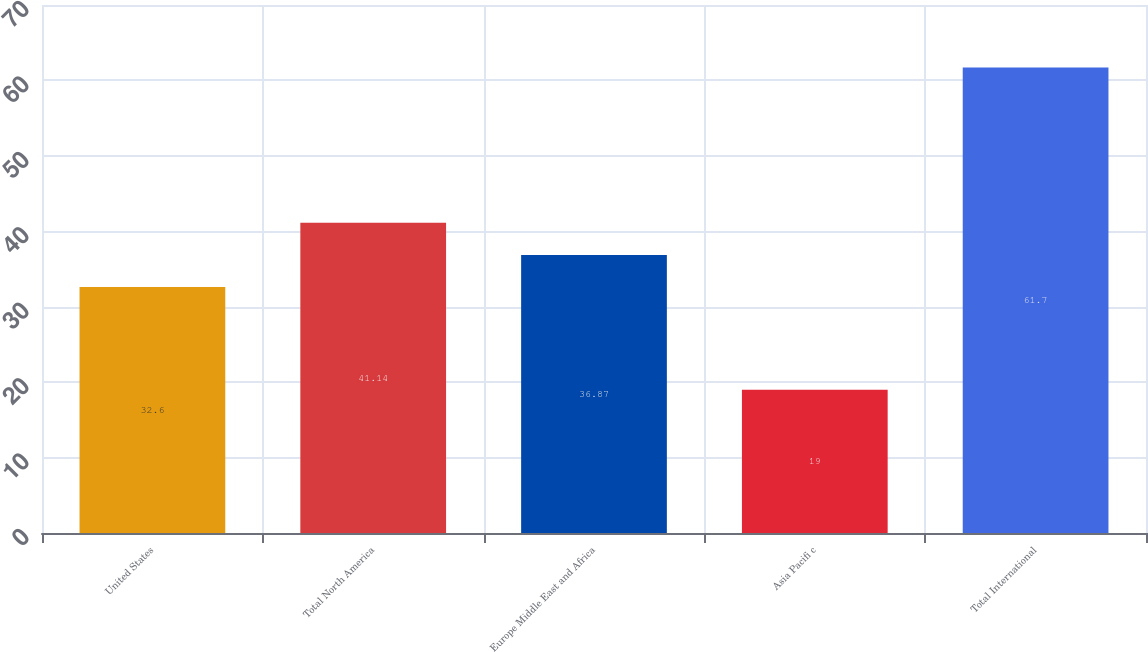Convert chart. <chart><loc_0><loc_0><loc_500><loc_500><bar_chart><fcel>United States<fcel>Total North America<fcel>Europe Middle East and Africa<fcel>Asia Pacifi c<fcel>Total International<nl><fcel>32.6<fcel>41.14<fcel>36.87<fcel>19<fcel>61.7<nl></chart> 